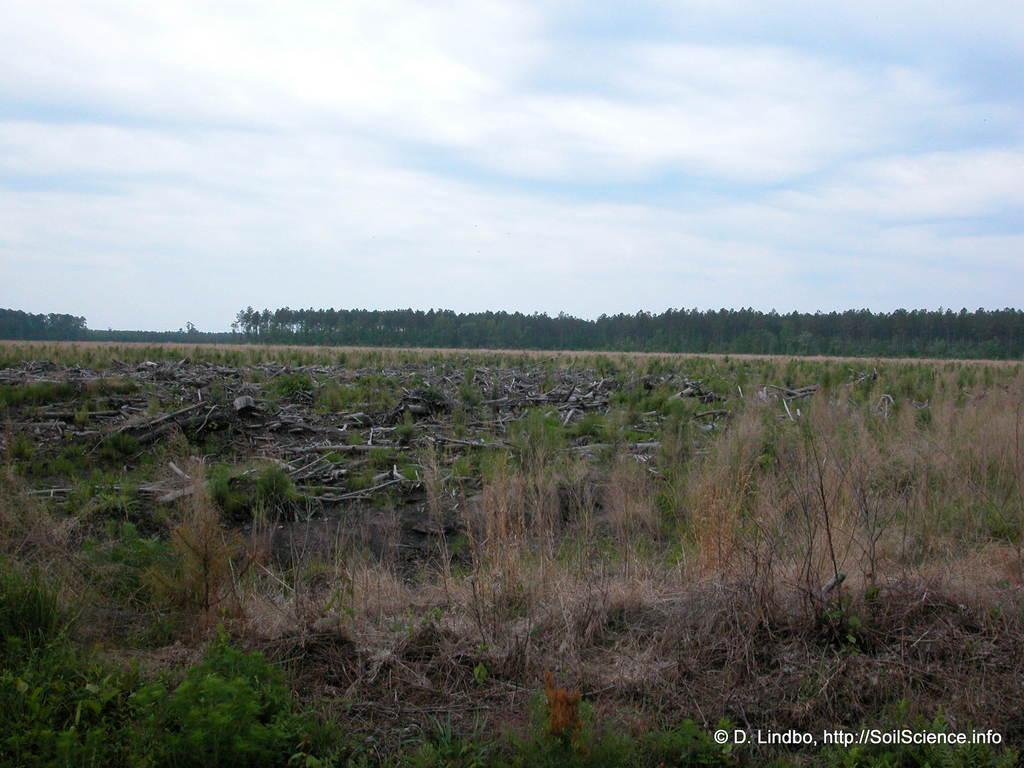What can be seen in the foreground of the picture? There are plants and grass in the foreground of the picture. What is located in the center of the picture? There are plants and wooden blocks in the center of the picture. What type of vegetation is visible in the background of the picture? There are trees in the background of the picture. How would you describe the sky in the image? The sky is cloudy. How many kittens are learning to play the piano in the image? There are no kittens or pianos present in the image. What type of sheet is covering the plants in the foreground? There is no sheet covering the plants in the foreground; they are visible and not obstructed. 